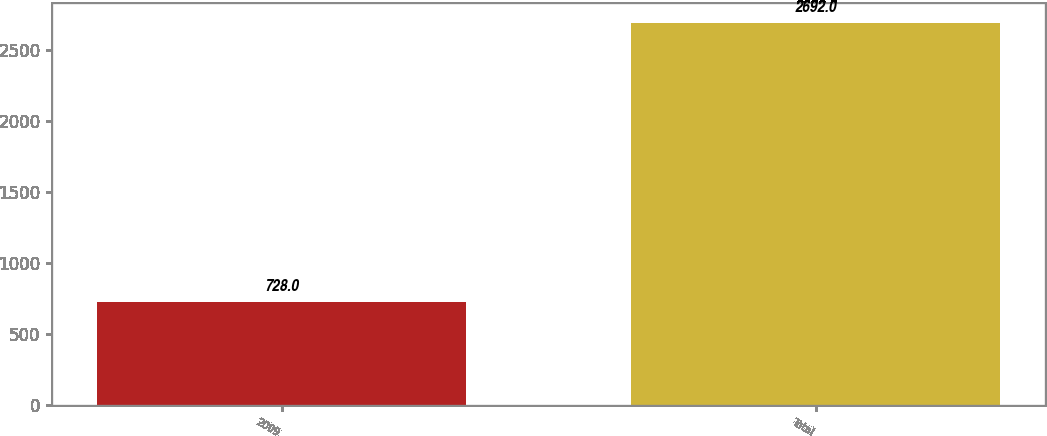Convert chart. <chart><loc_0><loc_0><loc_500><loc_500><bar_chart><fcel>2009<fcel>Total<nl><fcel>728<fcel>2692<nl></chart> 